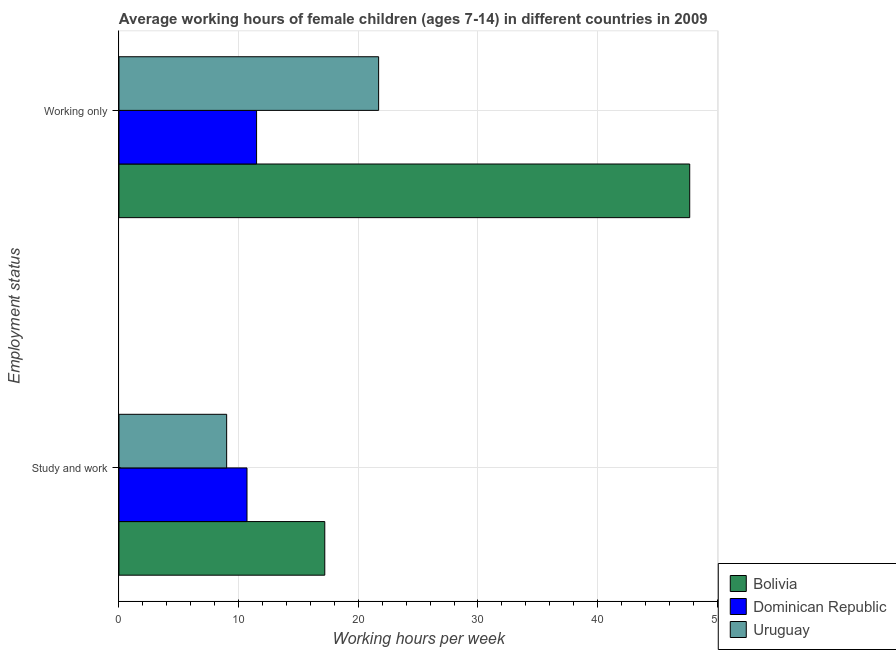Are the number of bars per tick equal to the number of legend labels?
Make the answer very short. Yes. Are the number of bars on each tick of the Y-axis equal?
Offer a very short reply. Yes. How many bars are there on the 1st tick from the bottom?
Give a very brief answer. 3. What is the label of the 1st group of bars from the top?
Offer a very short reply. Working only. What is the average working hour of children involved in only work in Uruguay?
Your answer should be very brief. 21.7. In which country was the average working hour of children involved in only work maximum?
Your answer should be very brief. Bolivia. In which country was the average working hour of children involved in only work minimum?
Give a very brief answer. Dominican Republic. What is the total average working hour of children involved in study and work in the graph?
Your answer should be very brief. 36.9. What is the difference between the average working hour of children involved in study and work in Uruguay and that in Dominican Republic?
Make the answer very short. -1.7. What is the difference between the average working hour of children involved in study and work in Dominican Republic and the average working hour of children involved in only work in Uruguay?
Make the answer very short. -11. What is the average average working hour of children involved in study and work per country?
Your answer should be very brief. 12.3. What is the difference between the average working hour of children involved in study and work and average working hour of children involved in only work in Uruguay?
Offer a terse response. -12.7. In how many countries, is the average working hour of children involved in only work greater than 24 hours?
Make the answer very short. 1. What is the ratio of the average working hour of children involved in only work in Dominican Republic to that in Bolivia?
Offer a very short reply. 0.24. Is the average working hour of children involved in study and work in Bolivia less than that in Dominican Republic?
Provide a short and direct response. No. In how many countries, is the average working hour of children involved in study and work greater than the average average working hour of children involved in study and work taken over all countries?
Provide a short and direct response. 1. What does the 2nd bar from the top in Study and work represents?
Give a very brief answer. Dominican Republic. What does the 3rd bar from the bottom in Working only represents?
Offer a terse response. Uruguay. How many bars are there?
Your response must be concise. 6. Are all the bars in the graph horizontal?
Your response must be concise. Yes. How many countries are there in the graph?
Your answer should be compact. 3. Are the values on the major ticks of X-axis written in scientific E-notation?
Offer a terse response. No. Does the graph contain grids?
Your answer should be compact. Yes. Where does the legend appear in the graph?
Provide a succinct answer. Bottom right. What is the title of the graph?
Offer a terse response. Average working hours of female children (ages 7-14) in different countries in 2009. What is the label or title of the X-axis?
Give a very brief answer. Working hours per week. What is the label or title of the Y-axis?
Give a very brief answer. Employment status. What is the Working hours per week in Uruguay in Study and work?
Offer a very short reply. 9. What is the Working hours per week in Bolivia in Working only?
Provide a succinct answer. 47.7. What is the Working hours per week in Uruguay in Working only?
Provide a short and direct response. 21.7. Across all Employment status, what is the maximum Working hours per week of Bolivia?
Your answer should be compact. 47.7. Across all Employment status, what is the maximum Working hours per week in Dominican Republic?
Your answer should be compact. 11.5. Across all Employment status, what is the maximum Working hours per week of Uruguay?
Your answer should be compact. 21.7. Across all Employment status, what is the minimum Working hours per week in Bolivia?
Provide a succinct answer. 17.2. Across all Employment status, what is the minimum Working hours per week of Uruguay?
Provide a short and direct response. 9. What is the total Working hours per week in Bolivia in the graph?
Make the answer very short. 64.9. What is the total Working hours per week of Uruguay in the graph?
Offer a terse response. 30.7. What is the difference between the Working hours per week of Bolivia in Study and work and that in Working only?
Provide a short and direct response. -30.5. What is the difference between the Working hours per week of Dominican Republic in Study and work and that in Working only?
Provide a short and direct response. -0.8. What is the difference between the Working hours per week of Uruguay in Study and work and that in Working only?
Give a very brief answer. -12.7. What is the difference between the Working hours per week in Bolivia in Study and work and the Working hours per week in Dominican Republic in Working only?
Offer a terse response. 5.7. What is the difference between the Working hours per week in Bolivia in Study and work and the Working hours per week in Uruguay in Working only?
Keep it short and to the point. -4.5. What is the average Working hours per week of Bolivia per Employment status?
Offer a very short reply. 32.45. What is the average Working hours per week in Dominican Republic per Employment status?
Offer a terse response. 11.1. What is the average Working hours per week in Uruguay per Employment status?
Provide a short and direct response. 15.35. What is the difference between the Working hours per week in Bolivia and Working hours per week in Uruguay in Study and work?
Make the answer very short. 8.2. What is the difference between the Working hours per week in Dominican Republic and Working hours per week in Uruguay in Study and work?
Your response must be concise. 1.7. What is the difference between the Working hours per week of Bolivia and Working hours per week of Dominican Republic in Working only?
Offer a terse response. 36.2. What is the difference between the Working hours per week of Dominican Republic and Working hours per week of Uruguay in Working only?
Provide a succinct answer. -10.2. What is the ratio of the Working hours per week in Bolivia in Study and work to that in Working only?
Offer a terse response. 0.36. What is the ratio of the Working hours per week in Dominican Republic in Study and work to that in Working only?
Make the answer very short. 0.93. What is the ratio of the Working hours per week of Uruguay in Study and work to that in Working only?
Give a very brief answer. 0.41. What is the difference between the highest and the second highest Working hours per week in Bolivia?
Make the answer very short. 30.5. What is the difference between the highest and the second highest Working hours per week of Dominican Republic?
Provide a short and direct response. 0.8. What is the difference between the highest and the second highest Working hours per week in Uruguay?
Provide a succinct answer. 12.7. What is the difference between the highest and the lowest Working hours per week in Bolivia?
Your answer should be compact. 30.5. What is the difference between the highest and the lowest Working hours per week of Dominican Republic?
Provide a succinct answer. 0.8. 